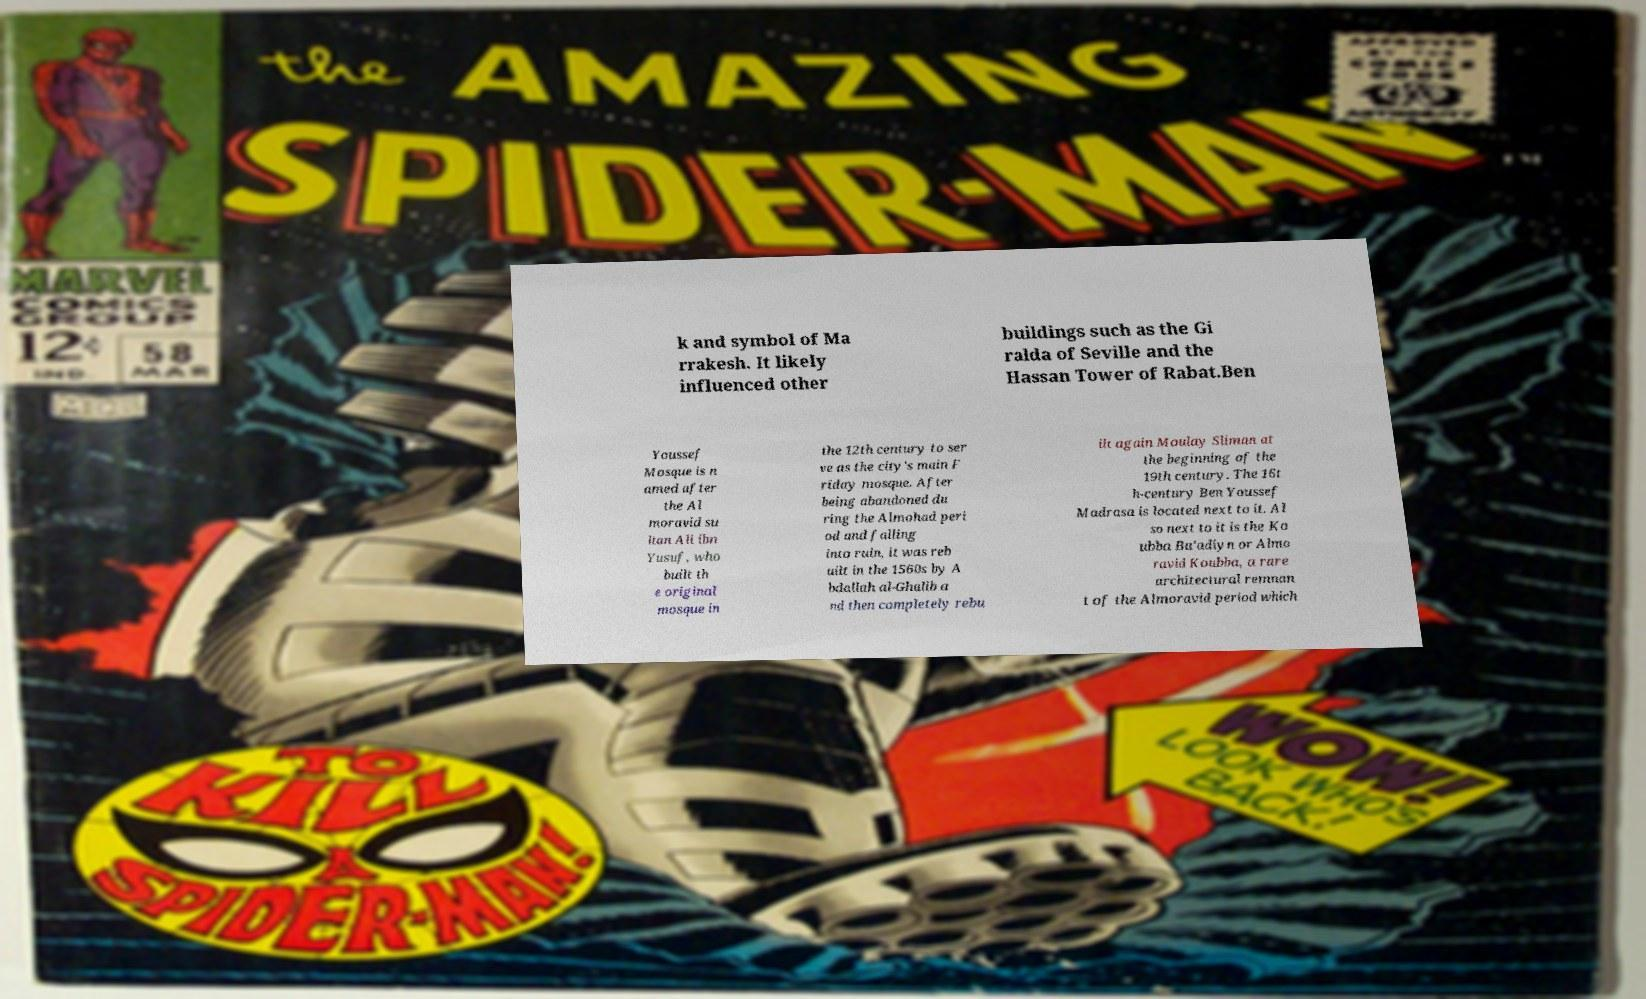Could you assist in decoding the text presented in this image and type it out clearly? k and symbol of Ma rrakesh. It likely influenced other buildings such as the Gi ralda of Seville and the Hassan Tower of Rabat.Ben Youssef Mosque is n amed after the Al moravid su ltan Ali ibn Yusuf, who built th e original mosque in the 12th century to ser ve as the city's main F riday mosque. After being abandoned du ring the Almohad peri od and falling into ruin, it was reb uilt in the 1560s by A bdallah al-Ghalib a nd then completely rebu ilt again Moulay Sliman at the beginning of the 19th century. The 16t h-century Ben Youssef Madrasa is located next to it. Al so next to it is the Ko ubba Ba’adiyn or Almo ravid Koubba, a rare architectural remnan t of the Almoravid period which 